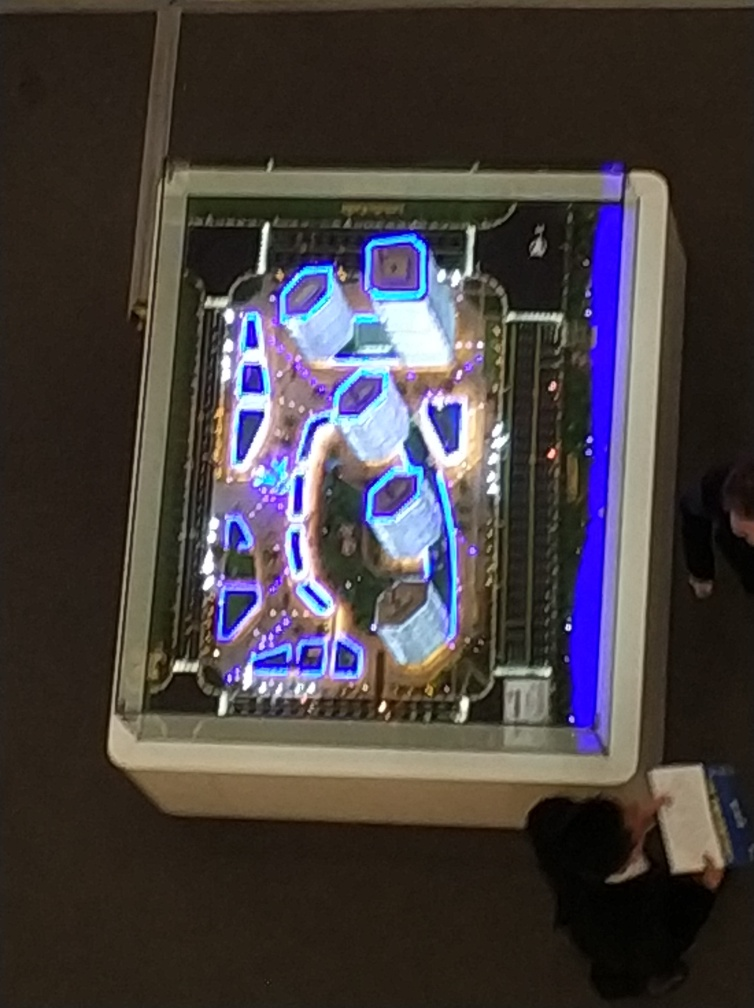Is the background blurry? The background is indeed blurry, which directs your attention to the illuminated, vibrant structures in the foreground, creating a beautiful contrast between sharpness and softness in the photo. 